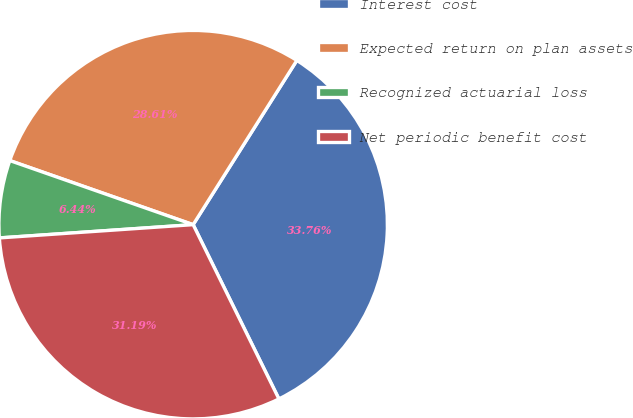Convert chart to OTSL. <chart><loc_0><loc_0><loc_500><loc_500><pie_chart><fcel>Interest cost<fcel>Expected return on plan assets<fcel>Recognized actuarial loss<fcel>Net periodic benefit cost<nl><fcel>33.76%<fcel>28.61%<fcel>6.44%<fcel>31.19%<nl></chart> 